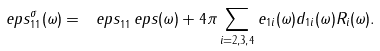<formula> <loc_0><loc_0><loc_500><loc_500>\ e p s _ { 1 1 } ^ { \sigma } ( \omega ) = \ e p s _ { 1 1 } ^ { \ } e p s ( \omega ) + 4 \pi \sum _ { i = 2 , 3 , 4 } e _ { 1 i } ( \omega ) d _ { 1 i } ( \omega ) R _ { i } ( \omega ) .</formula> 